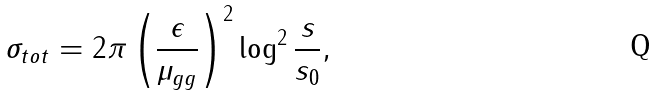<formula> <loc_0><loc_0><loc_500><loc_500>\sigma _ { t o t } = 2 \pi \left ( \frac { \epsilon } { \mu _ { g g } } \right ) ^ { 2 } \log ^ { 2 } \frac { s } { s _ { 0 } } ,</formula> 